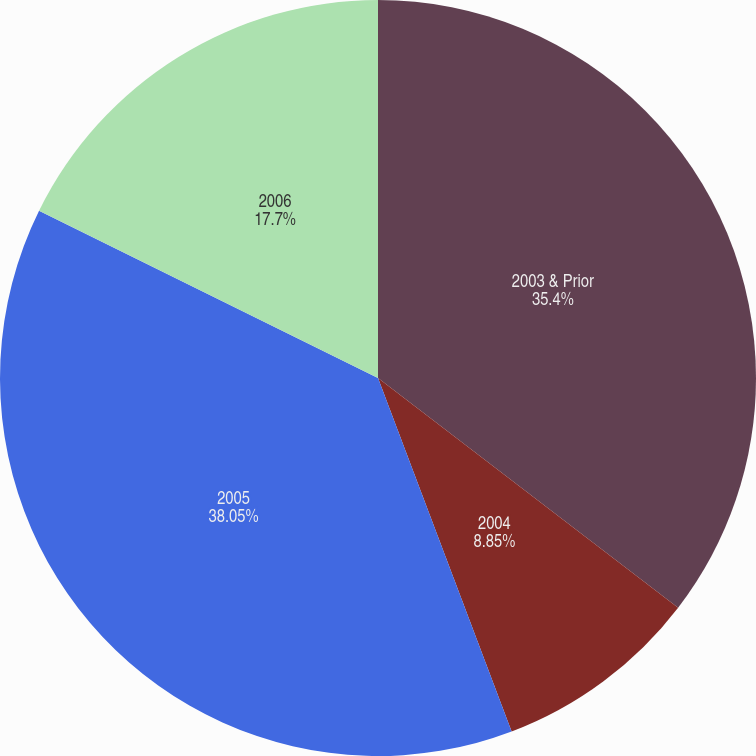<chart> <loc_0><loc_0><loc_500><loc_500><pie_chart><fcel>2003 & Prior<fcel>2004<fcel>2005<fcel>2006<nl><fcel>35.4%<fcel>8.85%<fcel>38.05%<fcel>17.7%<nl></chart> 